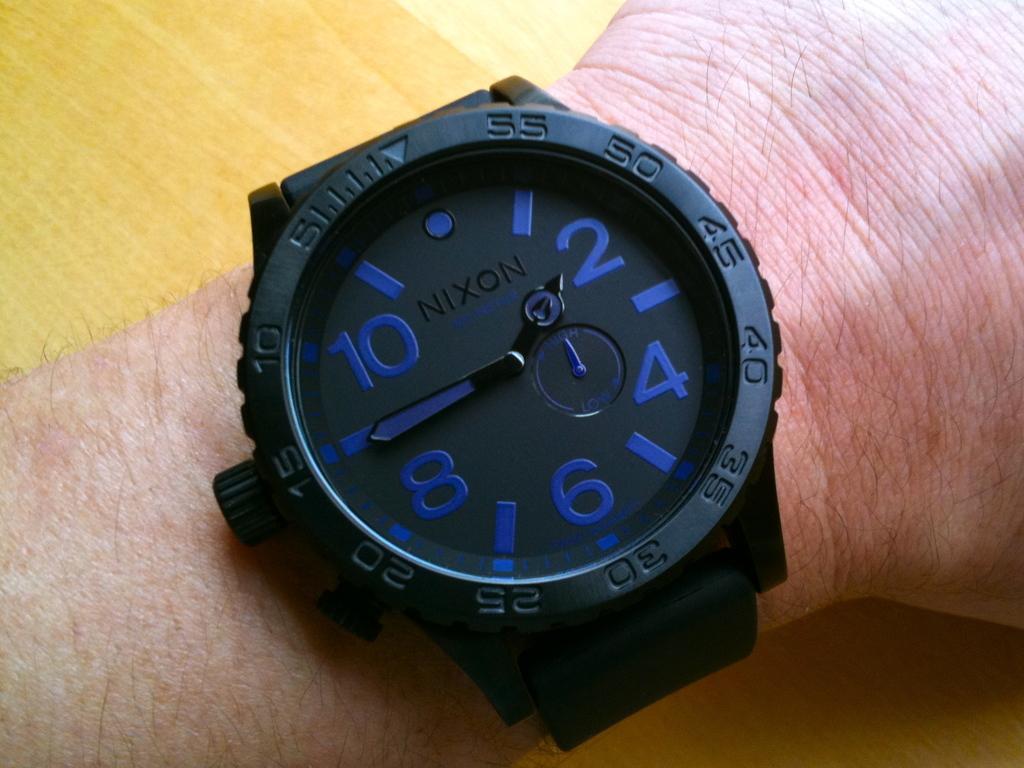In one or two sentences, can you explain what this image depicts? In the picture we can see some person's hand who is wearing wrist watch which is in black color and it is an analog watch. 